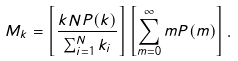Convert formula to latex. <formula><loc_0><loc_0><loc_500><loc_500>M _ { k } = \left [ \frac { k N P ( k ) } { \sum _ { i = 1 } ^ { N } k _ { i } } \right ] \left [ \sum _ { m = 0 } ^ { \infty } m P ( m ) \right ] .</formula> 